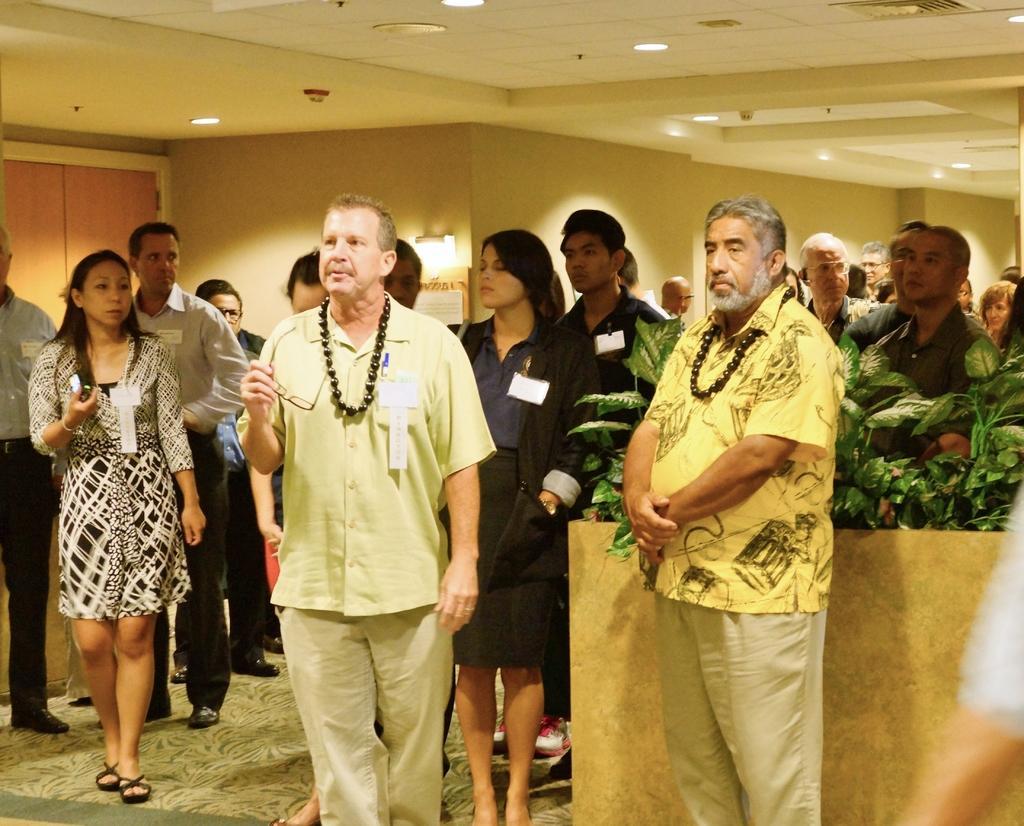Could you give a brief overview of what you see in this image? In this image, there are a few people. We can see the ground. We can see some plants. We can see a board and the wall. We can see some wood and we can see some lights on the roof. 